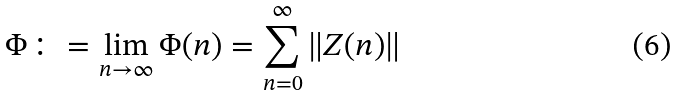Convert formula to latex. <formula><loc_0><loc_0><loc_500><loc_500>\Phi \colon = \lim _ { n \rightarrow \infty } \Phi ( n ) = \sum _ { n = 0 } ^ { \infty } \left \| Z ( n ) \right \|</formula> 